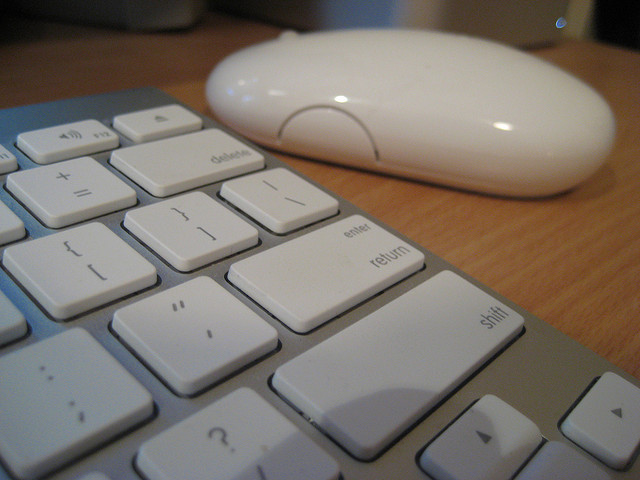Identify the text contained in this image. delete enter return 